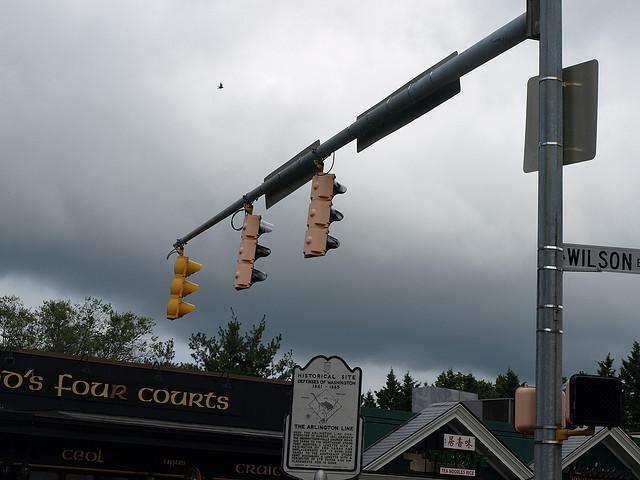Is it raining in the picture?
Quick response, please. No. What things are hanging from the pole?
Write a very short answer. Traffic lights. What is the street's name?
Short answer required. Wilson. Are there clouds in the sky?
Write a very short answer. Yes. 